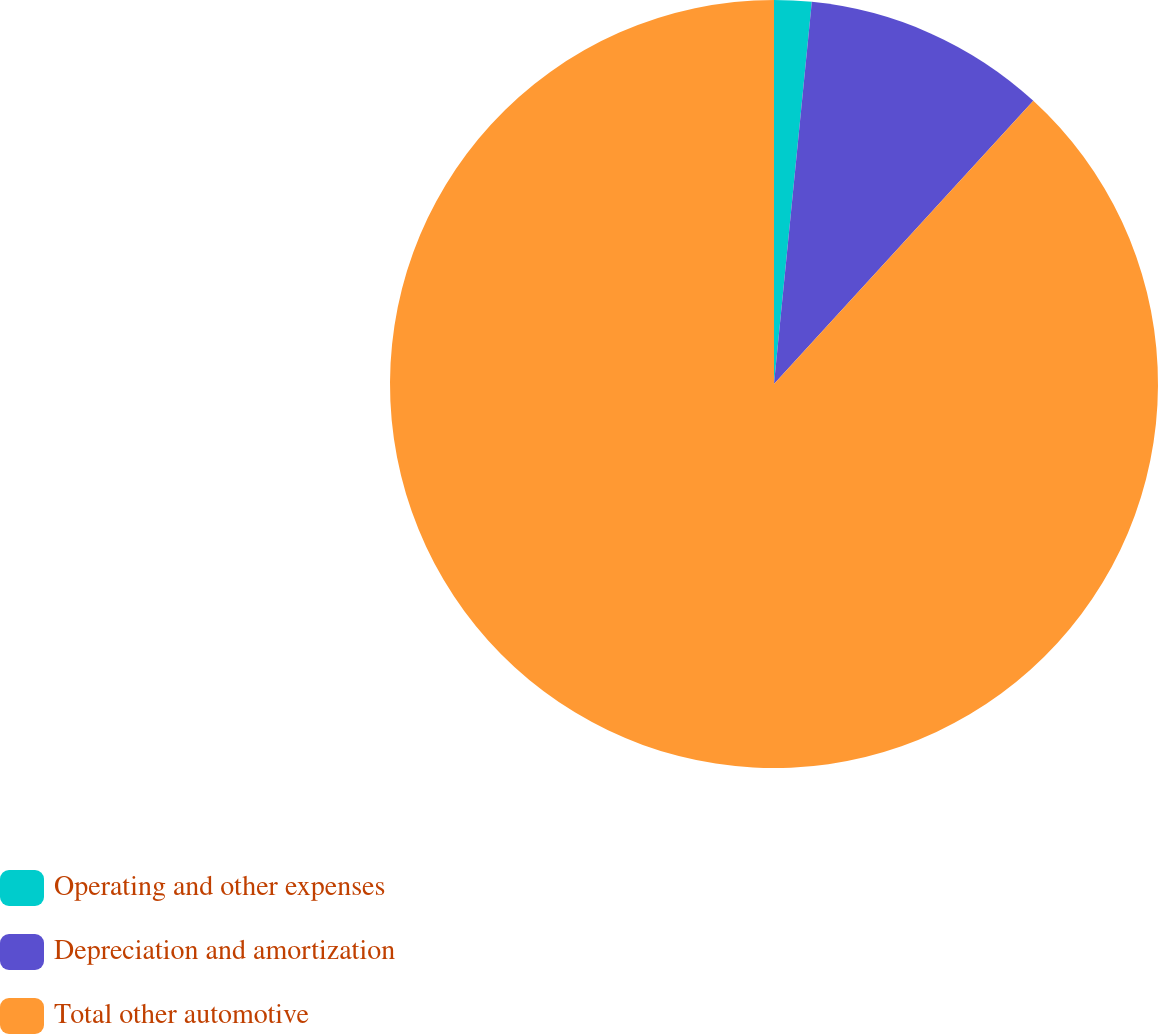Convert chart to OTSL. <chart><loc_0><loc_0><loc_500><loc_500><pie_chart><fcel>Operating and other expenses<fcel>Depreciation and amortization<fcel>Total other automotive<nl><fcel>1.57%<fcel>10.23%<fcel>88.2%<nl></chart> 